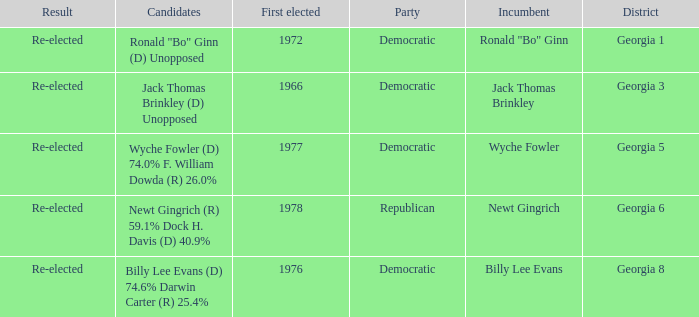What is the earliest first elected for district georgia 1? 1972.0. Could you parse the entire table as a dict? {'header': ['Result', 'Candidates', 'First elected', 'Party', 'Incumbent', 'District'], 'rows': [['Re-elected', 'Ronald "Bo" Ginn (D) Unopposed', '1972', 'Democratic', 'Ronald "Bo" Ginn', 'Georgia 1'], ['Re-elected', 'Jack Thomas Brinkley (D) Unopposed', '1966', 'Democratic', 'Jack Thomas Brinkley', 'Georgia 3'], ['Re-elected', 'Wyche Fowler (D) 74.0% F. William Dowda (R) 26.0%', '1977', 'Democratic', 'Wyche Fowler', 'Georgia 5'], ['Re-elected', 'Newt Gingrich (R) 59.1% Dock H. Davis (D) 40.9%', '1978', 'Republican', 'Newt Gingrich', 'Georgia 6'], ['Re-elected', 'Billy Lee Evans (D) 74.6% Darwin Carter (R) 25.4%', '1976', 'Democratic', 'Billy Lee Evans', 'Georgia 8']]} 